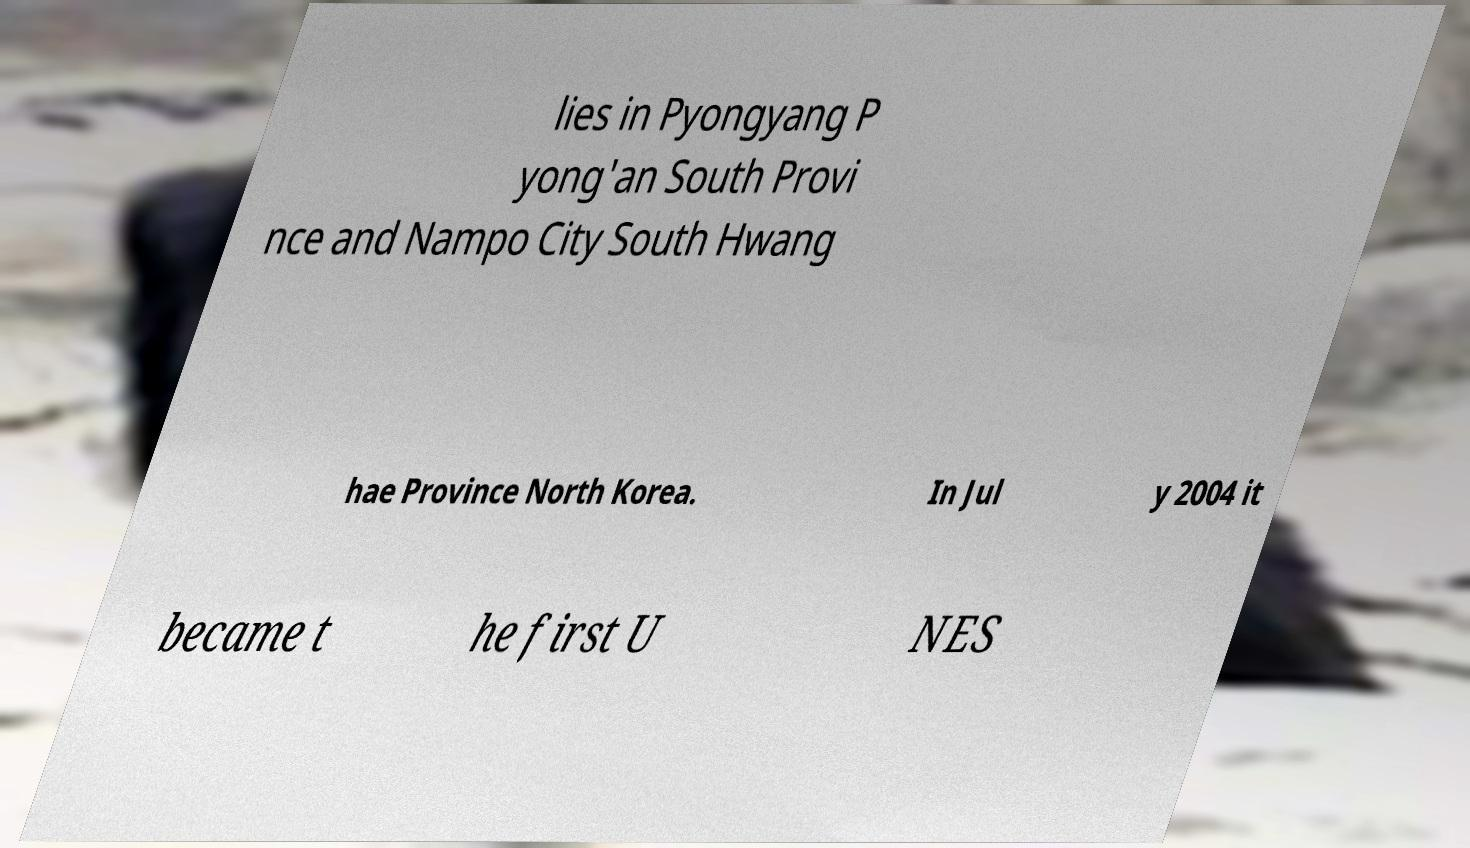Please identify and transcribe the text found in this image. lies in Pyongyang P yong'an South Provi nce and Nampo City South Hwang hae Province North Korea. In Jul y 2004 it became t he first U NES 